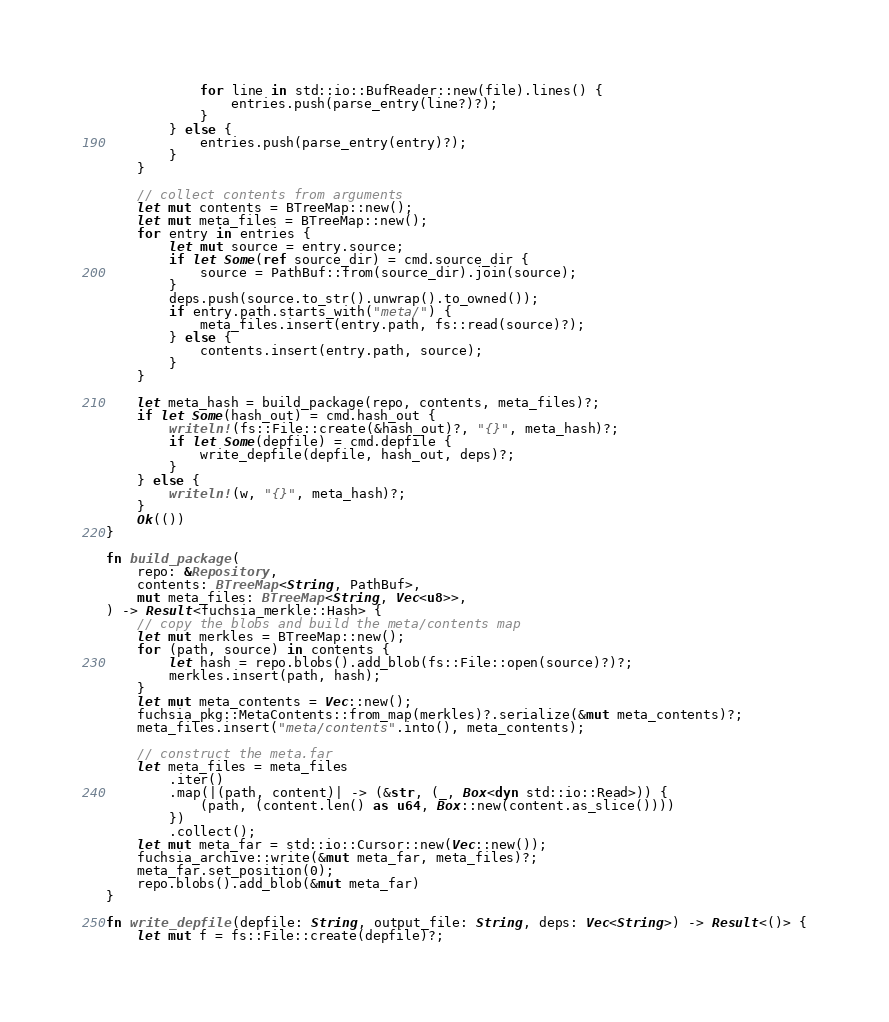<code> <loc_0><loc_0><loc_500><loc_500><_Rust_>            for line in std::io::BufReader::new(file).lines() {
                entries.push(parse_entry(line?)?);
            }
        } else {
            entries.push(parse_entry(entry)?);
        }
    }

    // collect contents from arguments
    let mut contents = BTreeMap::new();
    let mut meta_files = BTreeMap::new();
    for entry in entries {
        let mut source = entry.source;
        if let Some(ref source_dir) = cmd.source_dir {
            source = PathBuf::from(source_dir).join(source);
        }
        deps.push(source.to_str().unwrap().to_owned());
        if entry.path.starts_with("meta/") {
            meta_files.insert(entry.path, fs::read(source)?);
        } else {
            contents.insert(entry.path, source);
        }
    }

    let meta_hash = build_package(repo, contents, meta_files)?;
    if let Some(hash_out) = cmd.hash_out {
        writeln!(fs::File::create(&hash_out)?, "{}", meta_hash)?;
        if let Some(depfile) = cmd.depfile {
            write_depfile(depfile, hash_out, deps)?;
        }
    } else {
        writeln!(w, "{}", meta_hash)?;
    }
    Ok(())
}

fn build_package(
    repo: &Repository,
    contents: BTreeMap<String, PathBuf>,
    mut meta_files: BTreeMap<String, Vec<u8>>,
) -> Result<fuchsia_merkle::Hash> {
    // copy the blobs and build the meta/contents map
    let mut merkles = BTreeMap::new();
    for (path, source) in contents {
        let hash = repo.blobs().add_blob(fs::File::open(source)?)?;
        merkles.insert(path, hash);
    }
    let mut meta_contents = Vec::new();
    fuchsia_pkg::MetaContents::from_map(merkles)?.serialize(&mut meta_contents)?;
    meta_files.insert("meta/contents".into(), meta_contents);

    // construct the meta.far
    let meta_files = meta_files
        .iter()
        .map(|(path, content)| -> (&str, (_, Box<dyn std::io::Read>)) {
            (path, (content.len() as u64, Box::new(content.as_slice())))
        })
        .collect();
    let mut meta_far = std::io::Cursor::new(Vec::new());
    fuchsia_archive::write(&mut meta_far, meta_files)?;
    meta_far.set_position(0);
    repo.blobs().add_blob(&mut meta_far)
}

fn write_depfile(depfile: String, output_file: String, deps: Vec<String>) -> Result<()> {
    let mut f = fs::File::create(depfile)?;</code> 